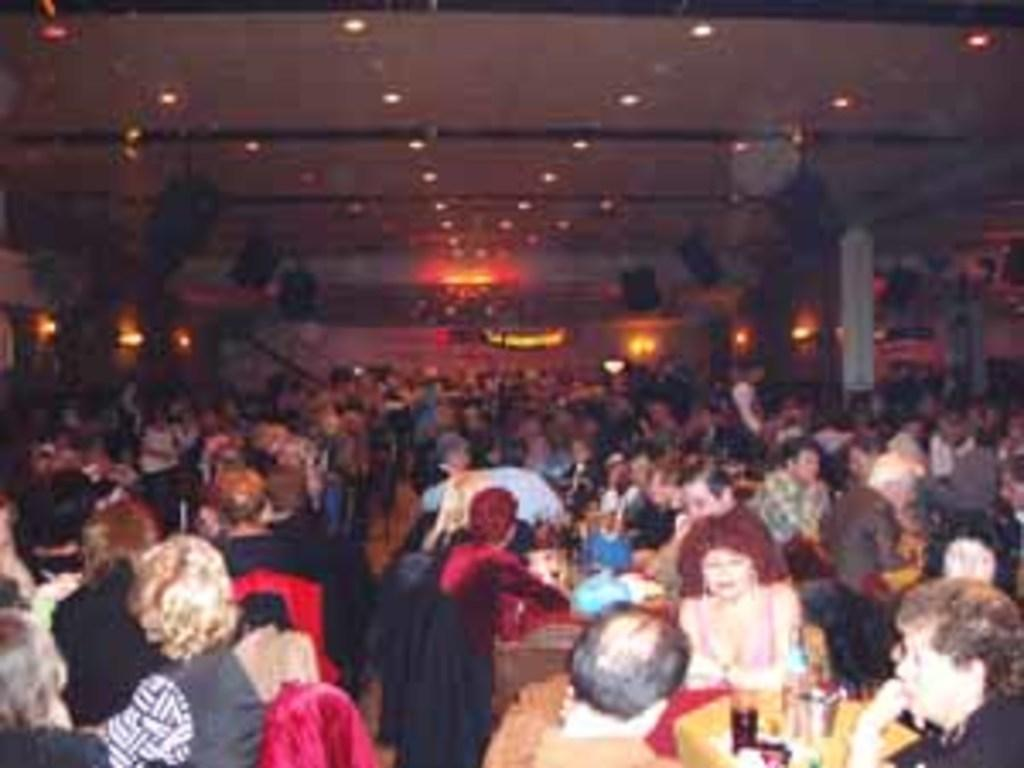What are the people in the image doing? The people in the image are sitting on chairs. What can be seen on the tables in the image? There are glasses and other objects on the tables in the image. What is providing illumination in the image? There are lights visible on top in the image. What type of coach is present in the image? There is no coach present in the image; it features people sitting on chairs and objects on tables. 